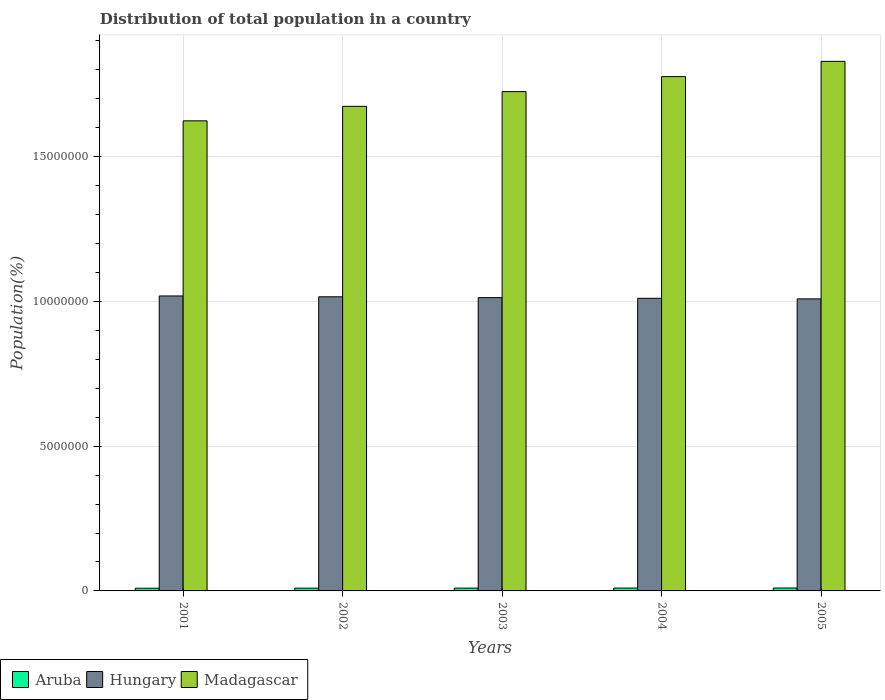How many different coloured bars are there?
Offer a very short reply. 3. How many groups of bars are there?
Offer a very short reply. 5. Are the number of bars per tick equal to the number of legend labels?
Ensure brevity in your answer.  Yes. Are the number of bars on each tick of the X-axis equal?
Provide a succinct answer. Yes. How many bars are there on the 1st tick from the right?
Your response must be concise. 3. What is the population of in Aruba in 2004?
Give a very brief answer. 9.87e+04. Across all years, what is the maximum population of in Hungary?
Ensure brevity in your answer.  1.02e+07. Across all years, what is the minimum population of in Madagascar?
Offer a very short reply. 1.62e+07. In which year was the population of in Madagascar minimum?
Make the answer very short. 2001. What is the total population of in Hungary in the graph?
Your answer should be compact. 5.07e+07. What is the difference between the population of in Aruba in 2002 and that in 2004?
Offer a terse response. -3747. What is the difference between the population of in Madagascar in 2003 and the population of in Aruba in 2004?
Provide a succinct answer. 1.71e+07. What is the average population of in Hungary per year?
Your response must be concise. 1.01e+07. In the year 2005, what is the difference between the population of in Aruba and population of in Madagascar?
Ensure brevity in your answer.  -1.82e+07. In how many years, is the population of in Madagascar greater than 3000000 %?
Provide a short and direct response. 5. What is the ratio of the population of in Aruba in 2001 to that in 2003?
Offer a terse response. 0.96. Is the population of in Madagascar in 2002 less than that in 2005?
Keep it short and to the point. Yes. Is the difference between the population of in Aruba in 2001 and 2005 greater than the difference between the population of in Madagascar in 2001 and 2005?
Provide a short and direct response. Yes. What is the difference between the highest and the second highest population of in Hungary?
Provide a short and direct response. 2.90e+04. What is the difference between the highest and the lowest population of in Hungary?
Your answer should be very brief. 1.01e+05. What does the 2nd bar from the left in 2002 represents?
Provide a succinct answer. Hungary. What does the 1st bar from the right in 2003 represents?
Your answer should be very brief. Madagascar. Is it the case that in every year, the sum of the population of in Hungary and population of in Aruba is greater than the population of in Madagascar?
Provide a succinct answer. No. How many bars are there?
Give a very brief answer. 15. What is the difference between two consecutive major ticks on the Y-axis?
Your answer should be very brief. 5.00e+06. Are the values on the major ticks of Y-axis written in scientific E-notation?
Your answer should be very brief. No. Does the graph contain any zero values?
Keep it short and to the point. No. Does the graph contain grids?
Provide a succinct answer. Yes. Where does the legend appear in the graph?
Provide a short and direct response. Bottom left. How many legend labels are there?
Offer a terse response. 3. How are the legend labels stacked?
Ensure brevity in your answer.  Horizontal. What is the title of the graph?
Provide a short and direct response. Distribution of total population in a country. Does "Faeroe Islands" appear as one of the legend labels in the graph?
Make the answer very short. No. What is the label or title of the X-axis?
Your answer should be very brief. Years. What is the label or title of the Y-axis?
Your answer should be very brief. Population(%). What is the Population(%) in Aruba in 2001?
Provide a short and direct response. 9.29e+04. What is the Population(%) of Hungary in 2001?
Your answer should be compact. 1.02e+07. What is the Population(%) in Madagascar in 2001?
Your response must be concise. 1.62e+07. What is the Population(%) of Aruba in 2002?
Give a very brief answer. 9.50e+04. What is the Population(%) in Hungary in 2002?
Make the answer very short. 1.02e+07. What is the Population(%) of Madagascar in 2002?
Your response must be concise. 1.67e+07. What is the Population(%) of Aruba in 2003?
Offer a very short reply. 9.70e+04. What is the Population(%) in Hungary in 2003?
Make the answer very short. 1.01e+07. What is the Population(%) of Madagascar in 2003?
Your response must be concise. 1.72e+07. What is the Population(%) of Aruba in 2004?
Your response must be concise. 9.87e+04. What is the Population(%) in Hungary in 2004?
Offer a very short reply. 1.01e+07. What is the Population(%) in Madagascar in 2004?
Your response must be concise. 1.78e+07. What is the Population(%) of Aruba in 2005?
Your answer should be compact. 1.00e+05. What is the Population(%) in Hungary in 2005?
Provide a succinct answer. 1.01e+07. What is the Population(%) in Madagascar in 2005?
Your answer should be very brief. 1.83e+07. Across all years, what is the maximum Population(%) in Aruba?
Keep it short and to the point. 1.00e+05. Across all years, what is the maximum Population(%) of Hungary?
Give a very brief answer. 1.02e+07. Across all years, what is the maximum Population(%) in Madagascar?
Keep it short and to the point. 1.83e+07. Across all years, what is the minimum Population(%) in Aruba?
Offer a very short reply. 9.29e+04. Across all years, what is the minimum Population(%) in Hungary?
Your response must be concise. 1.01e+07. Across all years, what is the minimum Population(%) of Madagascar?
Your answer should be very brief. 1.62e+07. What is the total Population(%) of Aruba in the graph?
Keep it short and to the point. 4.84e+05. What is the total Population(%) in Hungary in the graph?
Offer a very short reply. 5.07e+07. What is the total Population(%) in Madagascar in the graph?
Give a very brief answer. 8.63e+07. What is the difference between the Population(%) of Aruba in 2001 and that in 2002?
Your response must be concise. -2101. What is the difference between the Population(%) of Hungary in 2001 and that in 2002?
Offer a terse response. 2.90e+04. What is the difference between the Population(%) in Madagascar in 2001 and that in 2002?
Offer a very short reply. -5.00e+05. What is the difference between the Population(%) in Aruba in 2001 and that in 2003?
Your answer should be compact. -4121. What is the difference between the Population(%) in Hungary in 2001 and that in 2003?
Keep it short and to the point. 5.80e+04. What is the difference between the Population(%) in Madagascar in 2001 and that in 2003?
Provide a succinct answer. -1.01e+06. What is the difference between the Population(%) in Aruba in 2001 and that in 2004?
Give a very brief answer. -5848. What is the difference between the Population(%) of Hungary in 2001 and that in 2004?
Provide a short and direct response. 8.04e+04. What is the difference between the Population(%) in Madagascar in 2001 and that in 2004?
Offer a terse response. -1.53e+06. What is the difference between the Population(%) in Aruba in 2001 and that in 2005?
Give a very brief answer. -7137. What is the difference between the Population(%) in Hungary in 2001 and that in 2005?
Your response must be concise. 1.01e+05. What is the difference between the Population(%) of Madagascar in 2001 and that in 2005?
Your answer should be compact. -2.05e+06. What is the difference between the Population(%) of Aruba in 2002 and that in 2003?
Offer a very short reply. -2020. What is the difference between the Population(%) of Hungary in 2002 and that in 2003?
Your answer should be very brief. 2.91e+04. What is the difference between the Population(%) of Madagascar in 2002 and that in 2003?
Provide a short and direct response. -5.09e+05. What is the difference between the Population(%) in Aruba in 2002 and that in 2004?
Your answer should be very brief. -3747. What is the difference between the Population(%) of Hungary in 2002 and that in 2004?
Keep it short and to the point. 5.15e+04. What is the difference between the Population(%) of Madagascar in 2002 and that in 2004?
Provide a short and direct response. -1.03e+06. What is the difference between the Population(%) of Aruba in 2002 and that in 2005?
Your answer should be compact. -5036. What is the difference between the Population(%) in Hungary in 2002 and that in 2005?
Provide a short and direct response. 7.15e+04. What is the difference between the Population(%) of Madagascar in 2002 and that in 2005?
Offer a very short reply. -1.55e+06. What is the difference between the Population(%) in Aruba in 2003 and that in 2004?
Keep it short and to the point. -1727. What is the difference between the Population(%) of Hungary in 2003 and that in 2004?
Your response must be concise. 2.24e+04. What is the difference between the Population(%) of Madagascar in 2003 and that in 2004?
Your answer should be very brief. -5.18e+05. What is the difference between the Population(%) in Aruba in 2003 and that in 2005?
Make the answer very short. -3016. What is the difference between the Population(%) of Hungary in 2003 and that in 2005?
Your answer should be very brief. 4.25e+04. What is the difference between the Population(%) of Madagascar in 2003 and that in 2005?
Your answer should be compact. -1.05e+06. What is the difference between the Population(%) of Aruba in 2004 and that in 2005?
Ensure brevity in your answer.  -1289. What is the difference between the Population(%) in Hungary in 2004 and that in 2005?
Your answer should be compact. 2.01e+04. What is the difference between the Population(%) in Madagascar in 2004 and that in 2005?
Your response must be concise. -5.27e+05. What is the difference between the Population(%) in Aruba in 2001 and the Population(%) in Hungary in 2002?
Provide a succinct answer. -1.01e+07. What is the difference between the Population(%) in Aruba in 2001 and the Population(%) in Madagascar in 2002?
Provide a short and direct response. -1.66e+07. What is the difference between the Population(%) of Hungary in 2001 and the Population(%) of Madagascar in 2002?
Offer a very short reply. -6.55e+06. What is the difference between the Population(%) of Aruba in 2001 and the Population(%) of Hungary in 2003?
Make the answer very short. -1.00e+07. What is the difference between the Population(%) of Aruba in 2001 and the Population(%) of Madagascar in 2003?
Your response must be concise. -1.72e+07. What is the difference between the Population(%) in Hungary in 2001 and the Population(%) in Madagascar in 2003?
Your answer should be compact. -7.06e+06. What is the difference between the Population(%) of Aruba in 2001 and the Population(%) of Hungary in 2004?
Offer a terse response. -1.00e+07. What is the difference between the Population(%) of Aruba in 2001 and the Population(%) of Madagascar in 2004?
Ensure brevity in your answer.  -1.77e+07. What is the difference between the Population(%) in Hungary in 2001 and the Population(%) in Madagascar in 2004?
Your answer should be very brief. -7.58e+06. What is the difference between the Population(%) of Aruba in 2001 and the Population(%) of Hungary in 2005?
Provide a succinct answer. -9.99e+06. What is the difference between the Population(%) in Aruba in 2001 and the Population(%) in Madagascar in 2005?
Offer a very short reply. -1.82e+07. What is the difference between the Population(%) in Hungary in 2001 and the Population(%) in Madagascar in 2005?
Offer a terse response. -8.10e+06. What is the difference between the Population(%) in Aruba in 2002 and the Population(%) in Hungary in 2003?
Provide a short and direct response. -1.00e+07. What is the difference between the Population(%) in Aruba in 2002 and the Population(%) in Madagascar in 2003?
Ensure brevity in your answer.  -1.72e+07. What is the difference between the Population(%) in Hungary in 2002 and the Population(%) in Madagascar in 2003?
Your response must be concise. -7.09e+06. What is the difference between the Population(%) in Aruba in 2002 and the Population(%) in Hungary in 2004?
Make the answer very short. -1.00e+07. What is the difference between the Population(%) in Aruba in 2002 and the Population(%) in Madagascar in 2004?
Your answer should be compact. -1.77e+07. What is the difference between the Population(%) of Hungary in 2002 and the Population(%) of Madagascar in 2004?
Your response must be concise. -7.60e+06. What is the difference between the Population(%) in Aruba in 2002 and the Population(%) in Hungary in 2005?
Keep it short and to the point. -9.99e+06. What is the difference between the Population(%) of Aruba in 2002 and the Population(%) of Madagascar in 2005?
Your response must be concise. -1.82e+07. What is the difference between the Population(%) in Hungary in 2002 and the Population(%) in Madagascar in 2005?
Your answer should be compact. -8.13e+06. What is the difference between the Population(%) of Aruba in 2003 and the Population(%) of Hungary in 2004?
Your answer should be very brief. -1.00e+07. What is the difference between the Population(%) in Aruba in 2003 and the Population(%) in Madagascar in 2004?
Ensure brevity in your answer.  -1.77e+07. What is the difference between the Population(%) of Hungary in 2003 and the Population(%) of Madagascar in 2004?
Provide a short and direct response. -7.63e+06. What is the difference between the Population(%) of Aruba in 2003 and the Population(%) of Hungary in 2005?
Offer a terse response. -9.99e+06. What is the difference between the Population(%) in Aruba in 2003 and the Population(%) in Madagascar in 2005?
Keep it short and to the point. -1.82e+07. What is the difference between the Population(%) of Hungary in 2003 and the Population(%) of Madagascar in 2005?
Provide a succinct answer. -8.16e+06. What is the difference between the Population(%) in Aruba in 2004 and the Population(%) in Hungary in 2005?
Ensure brevity in your answer.  -9.99e+06. What is the difference between the Population(%) in Aruba in 2004 and the Population(%) in Madagascar in 2005?
Your answer should be very brief. -1.82e+07. What is the difference between the Population(%) of Hungary in 2004 and the Population(%) of Madagascar in 2005?
Your response must be concise. -8.18e+06. What is the average Population(%) of Aruba per year?
Provide a succinct answer. 9.67e+04. What is the average Population(%) in Hungary per year?
Ensure brevity in your answer.  1.01e+07. What is the average Population(%) of Madagascar per year?
Keep it short and to the point. 1.73e+07. In the year 2001, what is the difference between the Population(%) of Aruba and Population(%) of Hungary?
Your response must be concise. -1.01e+07. In the year 2001, what is the difference between the Population(%) of Aruba and Population(%) of Madagascar?
Your answer should be very brief. -1.61e+07. In the year 2001, what is the difference between the Population(%) of Hungary and Population(%) of Madagascar?
Offer a terse response. -6.05e+06. In the year 2002, what is the difference between the Population(%) of Aruba and Population(%) of Hungary?
Your answer should be very brief. -1.01e+07. In the year 2002, what is the difference between the Population(%) of Aruba and Population(%) of Madagascar?
Your response must be concise. -1.66e+07. In the year 2002, what is the difference between the Population(%) of Hungary and Population(%) of Madagascar?
Your answer should be very brief. -6.58e+06. In the year 2003, what is the difference between the Population(%) of Aruba and Population(%) of Hungary?
Offer a very short reply. -1.00e+07. In the year 2003, what is the difference between the Population(%) of Aruba and Population(%) of Madagascar?
Your answer should be very brief. -1.71e+07. In the year 2003, what is the difference between the Population(%) of Hungary and Population(%) of Madagascar?
Your answer should be compact. -7.12e+06. In the year 2004, what is the difference between the Population(%) in Aruba and Population(%) in Hungary?
Make the answer very short. -1.00e+07. In the year 2004, what is the difference between the Population(%) of Aruba and Population(%) of Madagascar?
Your answer should be compact. -1.77e+07. In the year 2004, what is the difference between the Population(%) of Hungary and Population(%) of Madagascar?
Offer a very short reply. -7.66e+06. In the year 2005, what is the difference between the Population(%) of Aruba and Population(%) of Hungary?
Give a very brief answer. -9.99e+06. In the year 2005, what is the difference between the Population(%) in Aruba and Population(%) in Madagascar?
Offer a terse response. -1.82e+07. In the year 2005, what is the difference between the Population(%) of Hungary and Population(%) of Madagascar?
Keep it short and to the point. -8.20e+06. What is the ratio of the Population(%) of Aruba in 2001 to that in 2002?
Provide a succinct answer. 0.98. What is the ratio of the Population(%) of Madagascar in 2001 to that in 2002?
Your answer should be very brief. 0.97. What is the ratio of the Population(%) in Aruba in 2001 to that in 2003?
Your answer should be compact. 0.96. What is the ratio of the Population(%) in Madagascar in 2001 to that in 2003?
Make the answer very short. 0.94. What is the ratio of the Population(%) of Aruba in 2001 to that in 2004?
Provide a succinct answer. 0.94. What is the ratio of the Population(%) of Madagascar in 2001 to that in 2004?
Give a very brief answer. 0.91. What is the ratio of the Population(%) of Aruba in 2001 to that in 2005?
Make the answer very short. 0.93. What is the ratio of the Population(%) of Hungary in 2001 to that in 2005?
Keep it short and to the point. 1.01. What is the ratio of the Population(%) in Madagascar in 2001 to that in 2005?
Give a very brief answer. 0.89. What is the ratio of the Population(%) in Aruba in 2002 to that in 2003?
Your answer should be very brief. 0.98. What is the ratio of the Population(%) of Madagascar in 2002 to that in 2003?
Ensure brevity in your answer.  0.97. What is the ratio of the Population(%) of Aruba in 2002 to that in 2004?
Provide a short and direct response. 0.96. What is the ratio of the Population(%) in Hungary in 2002 to that in 2004?
Your answer should be very brief. 1.01. What is the ratio of the Population(%) of Madagascar in 2002 to that in 2004?
Your answer should be compact. 0.94. What is the ratio of the Population(%) of Aruba in 2002 to that in 2005?
Provide a short and direct response. 0.95. What is the ratio of the Population(%) in Hungary in 2002 to that in 2005?
Make the answer very short. 1.01. What is the ratio of the Population(%) of Madagascar in 2002 to that in 2005?
Provide a succinct answer. 0.92. What is the ratio of the Population(%) in Aruba in 2003 to that in 2004?
Give a very brief answer. 0.98. What is the ratio of the Population(%) of Madagascar in 2003 to that in 2004?
Your response must be concise. 0.97. What is the ratio of the Population(%) in Aruba in 2003 to that in 2005?
Provide a succinct answer. 0.97. What is the ratio of the Population(%) of Madagascar in 2003 to that in 2005?
Provide a succinct answer. 0.94. What is the ratio of the Population(%) of Aruba in 2004 to that in 2005?
Your response must be concise. 0.99. What is the ratio of the Population(%) of Hungary in 2004 to that in 2005?
Ensure brevity in your answer.  1. What is the ratio of the Population(%) in Madagascar in 2004 to that in 2005?
Your answer should be very brief. 0.97. What is the difference between the highest and the second highest Population(%) in Aruba?
Provide a succinct answer. 1289. What is the difference between the highest and the second highest Population(%) in Hungary?
Make the answer very short. 2.90e+04. What is the difference between the highest and the second highest Population(%) in Madagascar?
Ensure brevity in your answer.  5.27e+05. What is the difference between the highest and the lowest Population(%) in Aruba?
Your response must be concise. 7137. What is the difference between the highest and the lowest Population(%) of Hungary?
Your answer should be compact. 1.01e+05. What is the difference between the highest and the lowest Population(%) in Madagascar?
Keep it short and to the point. 2.05e+06. 